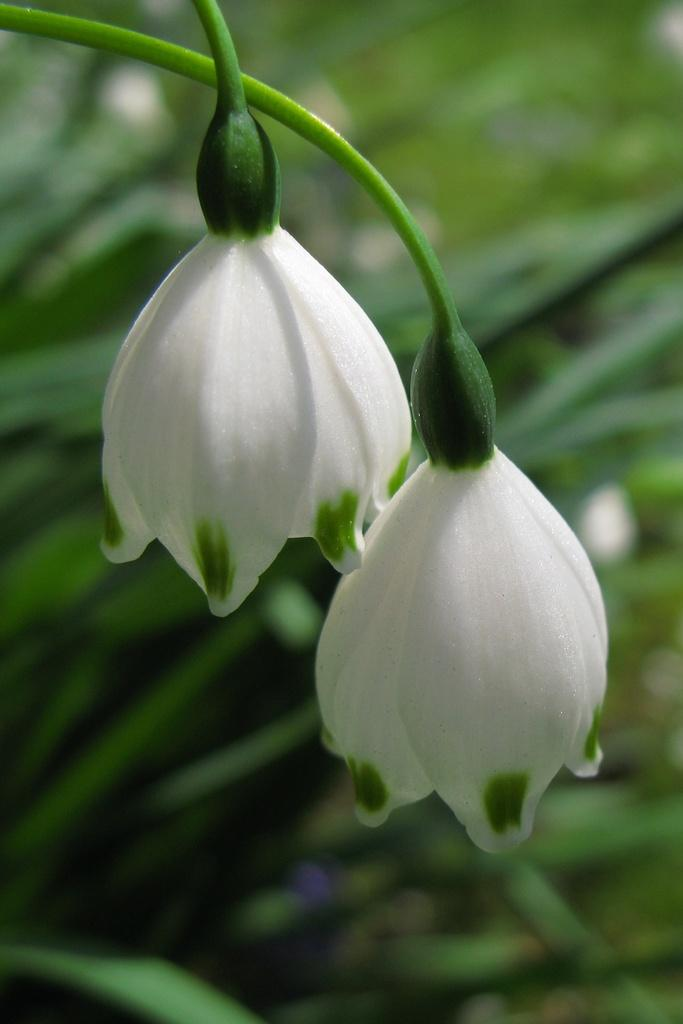What type of plant is visible in the image? There are flowers on the stems of a plant in the image. Can you describe the flowers on the plant? The flowers are on the stems of the plant, but their specific characteristics are not mentioned in the provided facts. What is the primary color of the flowers? The primary color of the flowers is not mentioned in the provided facts. What type of toys are scattered around the flowers in the image? There are no toys present in the image; it only features a plant with flowers on its stems. 